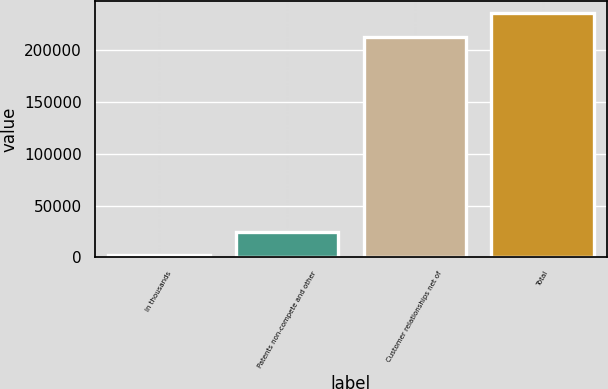<chart> <loc_0><loc_0><loc_500><loc_500><bar_chart><fcel>In thousands<fcel>Patents non-compete and other<fcel>Customer relationships net of<fcel>Total<nl><fcel>2013<fcel>24700.2<fcel>213324<fcel>236011<nl></chart> 